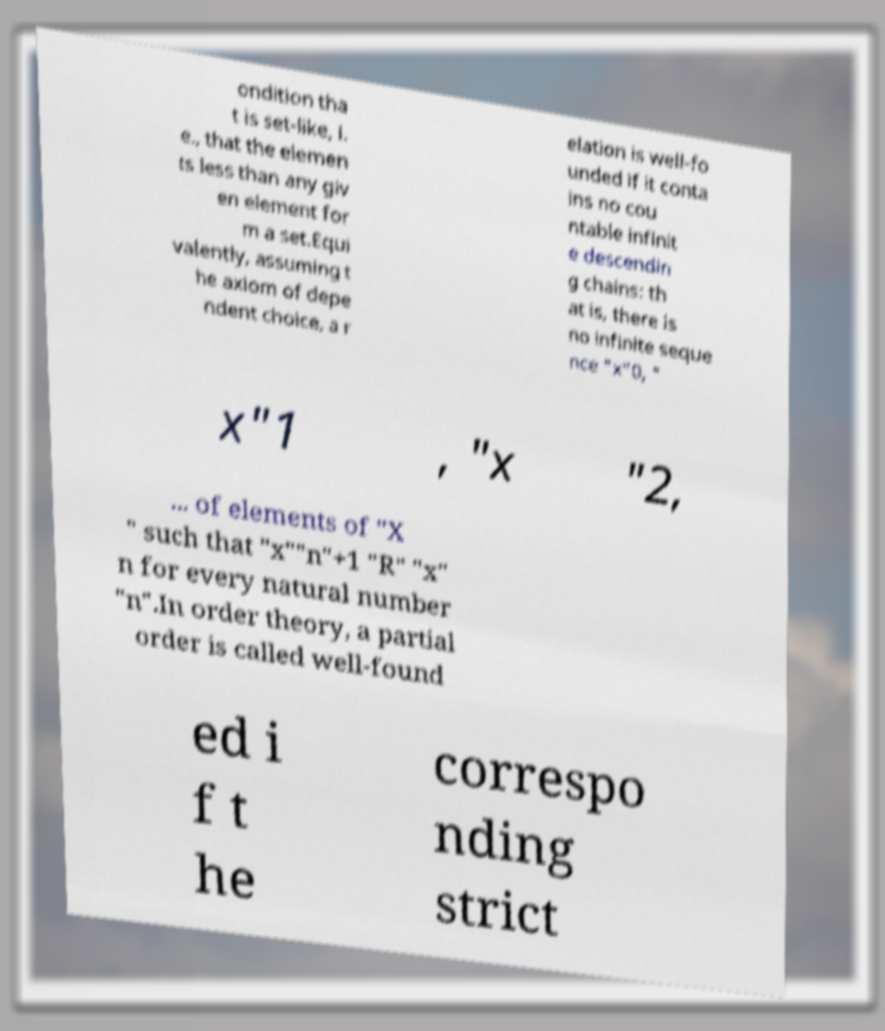Please read and relay the text visible in this image. What does it say? ondition tha t is set-like, i. e., that the elemen ts less than any giv en element for m a set.Equi valently, assuming t he axiom of depe ndent choice, a r elation is well-fo unded if it conta ins no cou ntable infinit e descendin g chains: th at is, there is no infinite seque nce "x"0, " x"1 , "x "2, ... of elements of "X " such that "x""n"+1 "R" "x" n for every natural number "n".In order theory, a partial order is called well-found ed i f t he correspo nding strict 